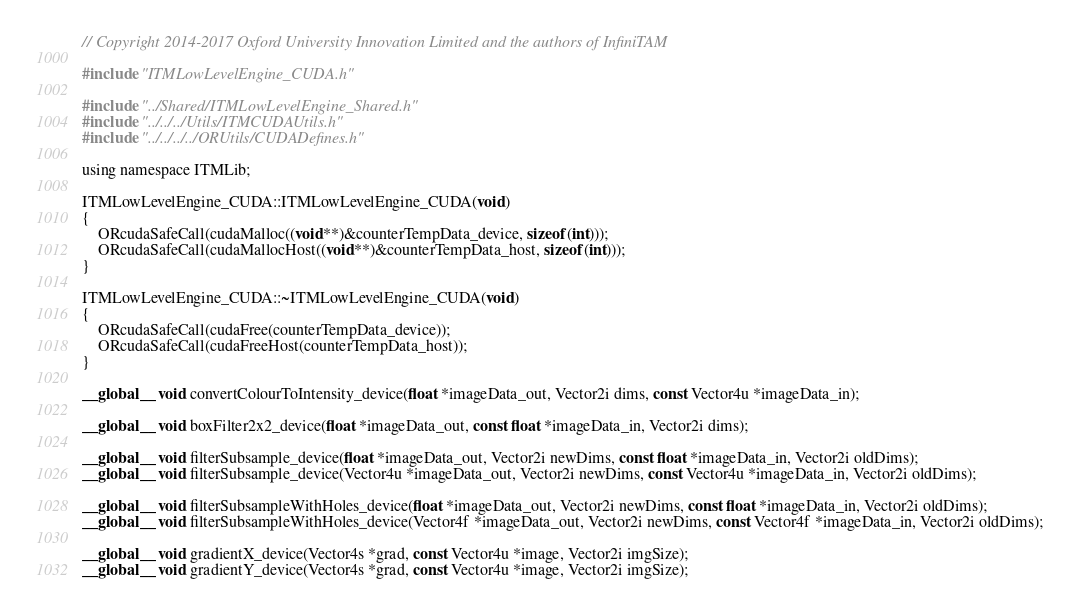<code> <loc_0><loc_0><loc_500><loc_500><_Cuda_>// Copyright 2014-2017 Oxford University Innovation Limited and the authors of InfiniTAM

#include "ITMLowLevelEngine_CUDA.h"

#include "../Shared/ITMLowLevelEngine_Shared.h"
#include "../../../Utils/ITMCUDAUtils.h"
#include "../../../../ORUtils/CUDADefines.h"

using namespace ITMLib;

ITMLowLevelEngine_CUDA::ITMLowLevelEngine_CUDA(void)
{
	ORcudaSafeCall(cudaMalloc((void**)&counterTempData_device, sizeof(int)));
	ORcudaSafeCall(cudaMallocHost((void**)&counterTempData_host, sizeof(int)));
}

ITMLowLevelEngine_CUDA::~ITMLowLevelEngine_CUDA(void)
{
	ORcudaSafeCall(cudaFree(counterTempData_device));
	ORcudaSafeCall(cudaFreeHost(counterTempData_host));
}

__global__ void convertColourToIntensity_device(float *imageData_out, Vector2i dims, const Vector4u *imageData_in);

__global__ void boxFilter2x2_device(float *imageData_out, const float *imageData_in, Vector2i dims);

__global__ void filterSubsample_device(float *imageData_out, Vector2i newDims, const float *imageData_in, Vector2i oldDims);
__global__ void filterSubsample_device(Vector4u *imageData_out, Vector2i newDims, const Vector4u *imageData_in, Vector2i oldDims);

__global__ void filterSubsampleWithHoles_device(float *imageData_out, Vector2i newDims, const float *imageData_in, Vector2i oldDims);
__global__ void filterSubsampleWithHoles_device(Vector4f *imageData_out, Vector2i newDims, const Vector4f *imageData_in, Vector2i oldDims);

__global__ void gradientX_device(Vector4s *grad, const Vector4u *image, Vector2i imgSize);
__global__ void gradientY_device(Vector4s *grad, const Vector4u *image, Vector2i imgSize);</code> 